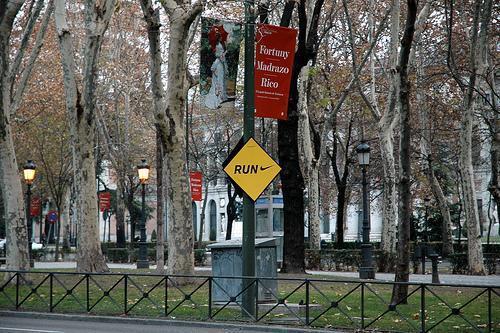How many lights are on?
Give a very brief answer. 2. How many banners are in the foreground?
Give a very brief answer. 2. 